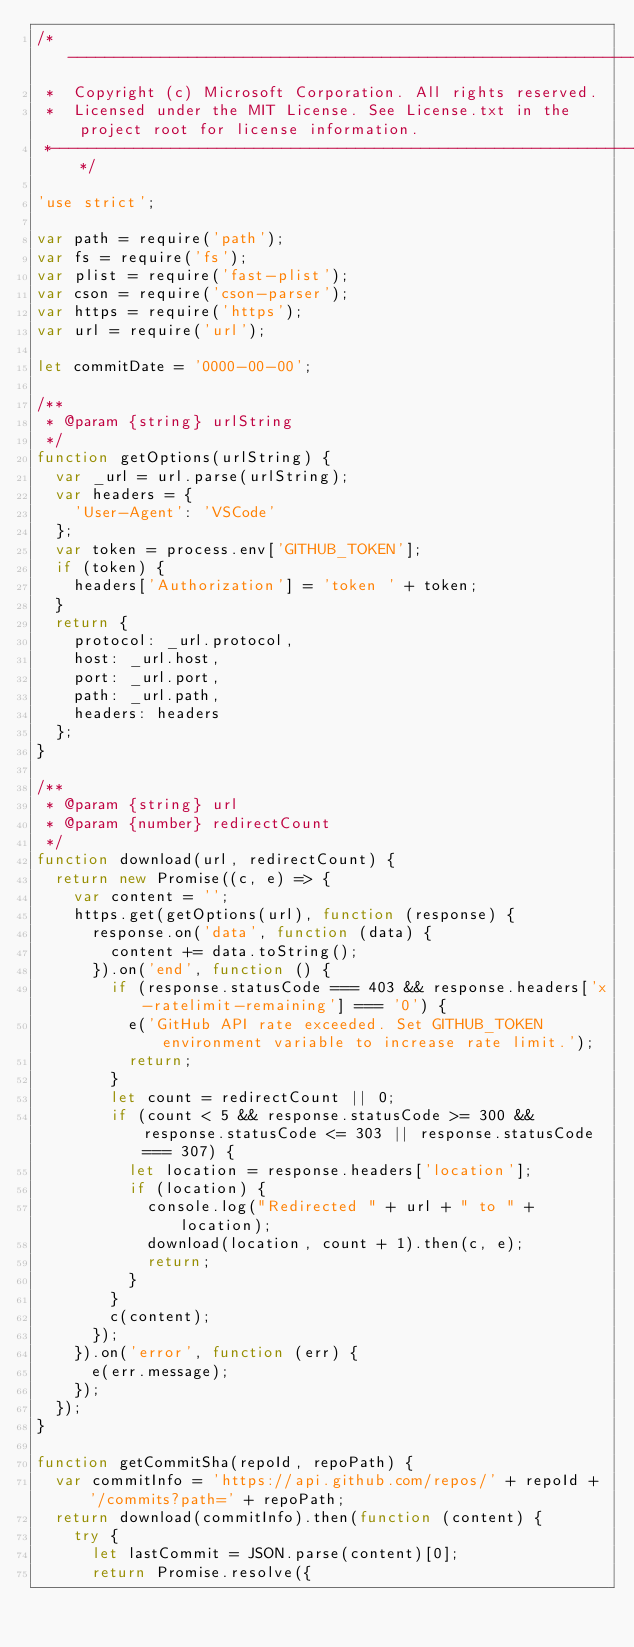Convert code to text. <code><loc_0><loc_0><loc_500><loc_500><_JavaScript_>/*---------------------------------------------------------------------------------------------
 *  Copyright (c) Microsoft Corporation. All rights reserved.
 *  Licensed under the MIT License. See License.txt in the project root for license information.
 *--------------------------------------------------------------------------------------------*/

'use strict';

var path = require('path');
var fs = require('fs');
var plist = require('fast-plist');
var cson = require('cson-parser');
var https = require('https');
var url = require('url');

let commitDate = '0000-00-00';

/**
 * @param {string} urlString
 */
function getOptions(urlString) {
	var _url = url.parse(urlString);
	var headers = {
		'User-Agent': 'VSCode'
	};
	var token = process.env['GITHUB_TOKEN'];
	if (token) {
		headers['Authorization'] = 'token ' + token;
	}
	return {
		protocol: _url.protocol,
		host: _url.host,
		port: _url.port,
		path: _url.path,
		headers: headers
	};
}

/**
 * @param {string} url
 * @param {number} redirectCount
 */
function download(url, redirectCount) {
	return new Promise((c, e) => {
		var content = '';
		https.get(getOptions(url), function (response) {
			response.on('data', function (data) {
				content += data.toString();
			}).on('end', function () {
				if (response.statusCode === 403 && response.headers['x-ratelimit-remaining'] === '0') {
					e('GitHub API rate exceeded. Set GITHUB_TOKEN environment variable to increase rate limit.');
					return;
				}
				let count = redirectCount || 0;
				if (count < 5 && response.statusCode >= 300 && response.statusCode <= 303 || response.statusCode === 307) {
					let location = response.headers['location'];
					if (location) {
						console.log("Redirected " + url + " to " + location);
						download(location, count + 1).then(c, e);
						return;
					}
				}
				c(content);
			});
		}).on('error', function (err) {
			e(err.message);
		});
	});
}

function getCommitSha(repoId, repoPath) {
	var commitInfo = 'https://api.github.com/repos/' + repoId + '/commits?path=' + repoPath;
	return download(commitInfo).then(function (content) {
		try {
			let lastCommit = JSON.parse(content)[0];
			return Promise.resolve({</code> 